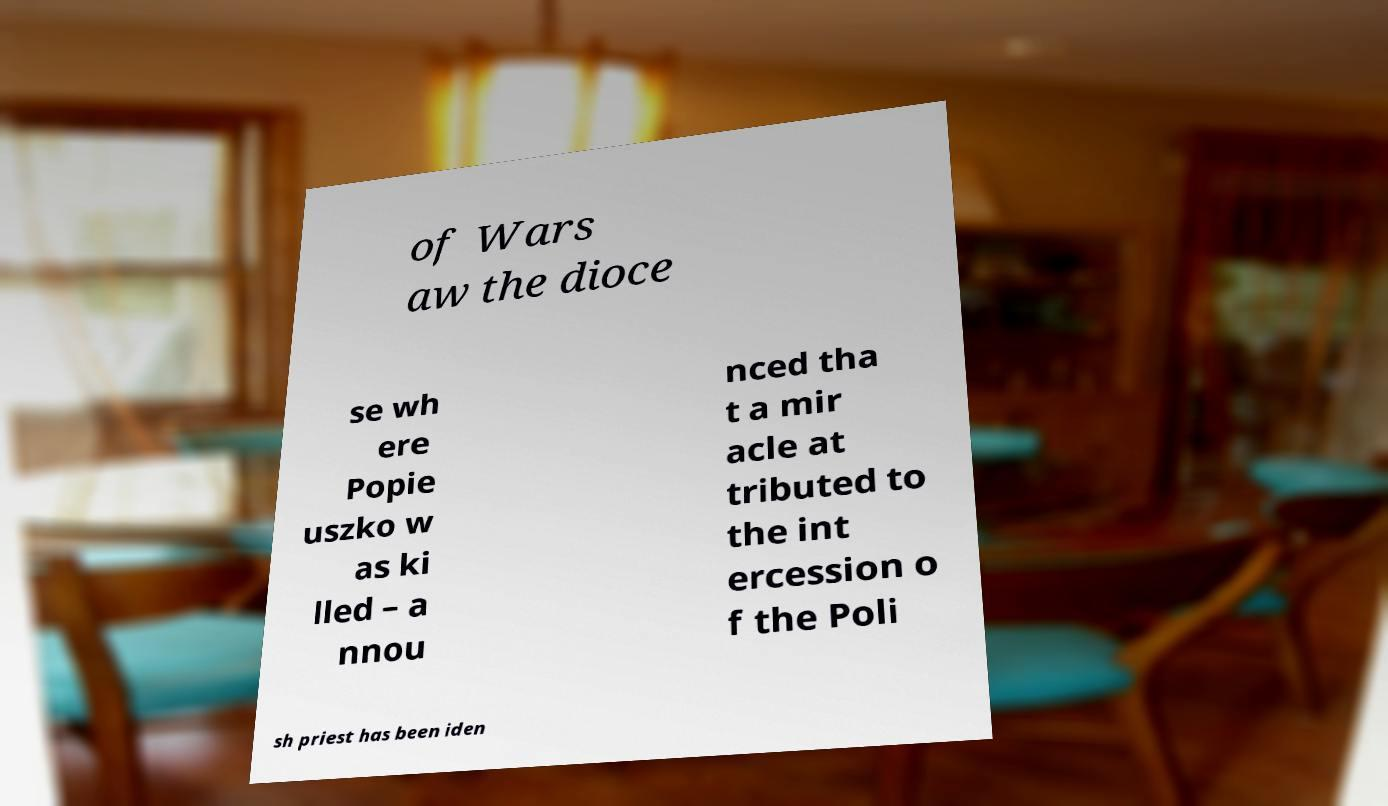I need the written content from this picture converted into text. Can you do that? of Wars aw the dioce se wh ere Popie uszko w as ki lled – a nnou nced tha t a mir acle at tributed to the int ercession o f the Poli sh priest has been iden 